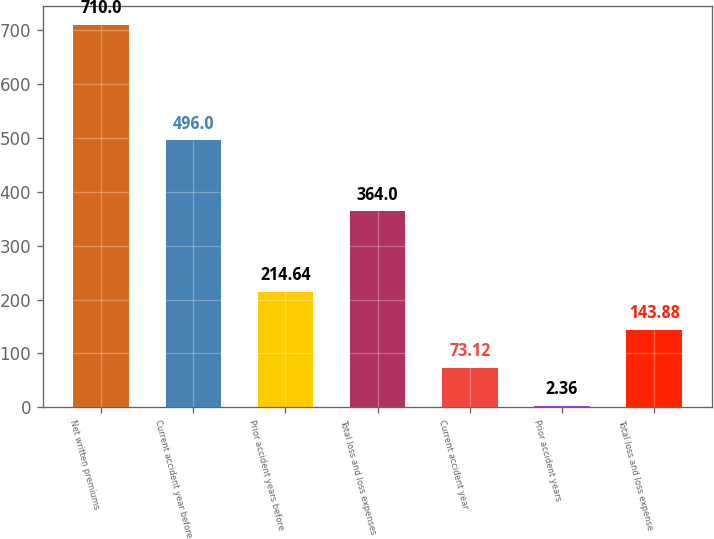Convert chart to OTSL. <chart><loc_0><loc_0><loc_500><loc_500><bar_chart><fcel>Net written premiums<fcel>Current accident year before<fcel>Prior accident years before<fcel>Total loss and loss expenses<fcel>Current accident year<fcel>Prior accident years<fcel>Total loss and loss expense<nl><fcel>710<fcel>496<fcel>214.64<fcel>364<fcel>73.12<fcel>2.36<fcel>143.88<nl></chart> 